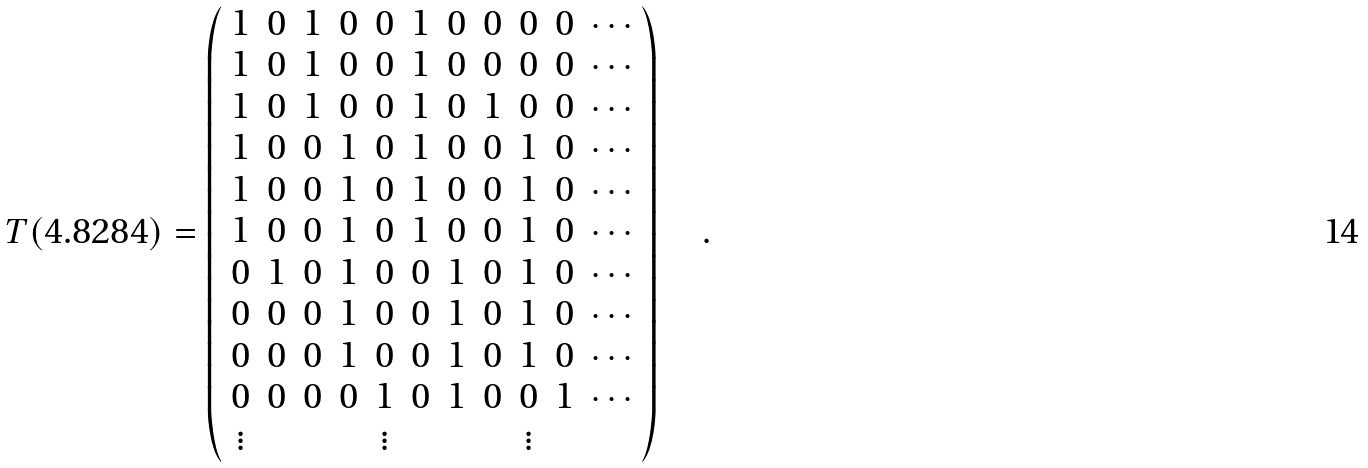Convert formula to latex. <formula><loc_0><loc_0><loc_500><loc_500>T ( 4 . 8 2 8 4 ) = \left ( \begin{array} { c c c c c c c c c c c } 1 & 0 & 1 & 0 & 0 & 1 & 0 & 0 & 0 & 0 & \cdots \\ 1 & 0 & 1 & 0 & 0 & 1 & 0 & 0 & 0 & 0 & \cdots \\ 1 & 0 & 1 & 0 & 0 & 1 & 0 & 1 & 0 & 0 & \cdots \\ 1 & 0 & 0 & 1 & 0 & 1 & 0 & 0 & 1 & 0 & \cdots \\ 1 & 0 & 0 & 1 & 0 & 1 & 0 & 0 & 1 & 0 & \cdots \\ 1 & 0 & 0 & 1 & 0 & 1 & 0 & 0 & 1 & 0 & \cdots \\ 0 & 1 & 0 & 1 & 0 & 0 & 1 & 0 & 1 & 0 & \cdots \\ 0 & 0 & 0 & 1 & 0 & 0 & 1 & 0 & 1 & 0 & \cdots \\ 0 & 0 & 0 & 1 & 0 & 0 & 1 & 0 & 1 & 0 & \cdots \\ 0 & 0 & 0 & 0 & 1 & 0 & 1 & 0 & 0 & 1 & \cdots \\ \vdots & & & & \vdots & & & & \vdots \\ \end{array} \right ) \quad .</formula> 